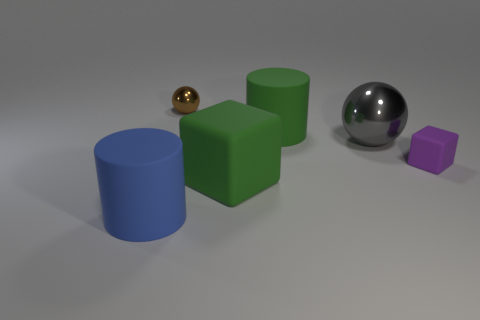There is a cylinder behind the big blue thing; is it the same size as the shiny ball behind the gray ball?
Provide a succinct answer. No. There is a rubber block that is behind the large green block; what size is it?
Your response must be concise. Small. What is the material of the big cylinder that is the same color as the big matte cube?
Your response must be concise. Rubber. There is a cube that is the same size as the gray object; what is its color?
Make the answer very short. Green. Is the size of the purple thing the same as the brown shiny ball?
Ensure brevity in your answer.  Yes. There is a object that is both right of the big green rubber cylinder and in front of the gray metallic thing; what is its size?
Offer a very short reply. Small. What number of rubber objects are large balls or green blocks?
Your answer should be compact. 1. Is the number of small matte things on the left side of the large blue cylinder greater than the number of matte cylinders?
Offer a very short reply. No. What is the cube that is right of the gray metal ball made of?
Provide a succinct answer. Rubber. What number of tiny purple cubes have the same material as the blue cylinder?
Offer a terse response. 1. 